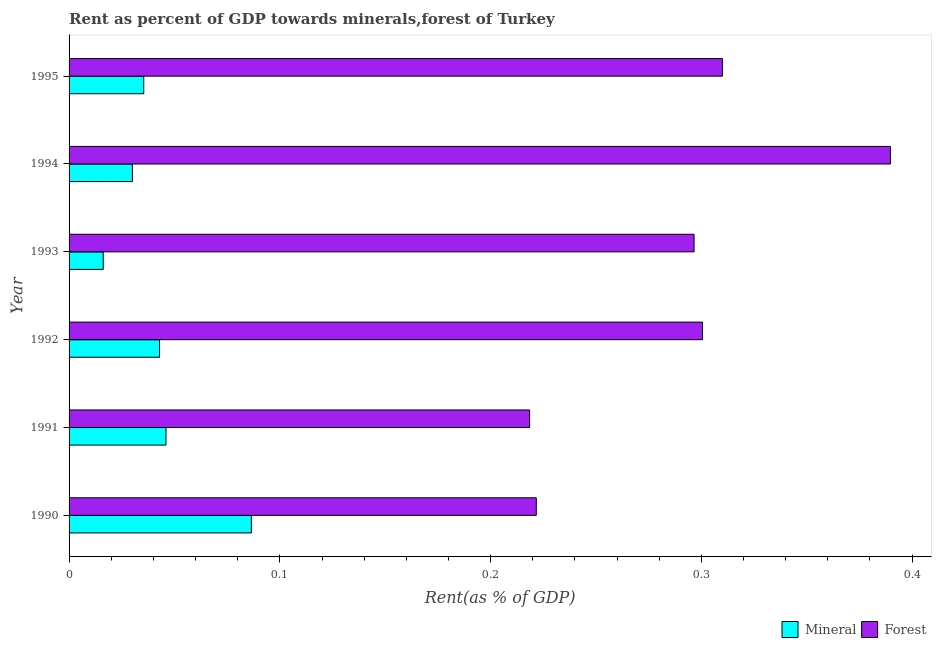How many different coloured bars are there?
Keep it short and to the point. 2. How many bars are there on the 4th tick from the top?
Your answer should be very brief. 2. How many bars are there on the 4th tick from the bottom?
Ensure brevity in your answer.  2. In how many cases, is the number of bars for a given year not equal to the number of legend labels?
Your answer should be very brief. 0. What is the forest rent in 1994?
Offer a very short reply. 0.39. Across all years, what is the maximum forest rent?
Give a very brief answer. 0.39. Across all years, what is the minimum mineral rent?
Offer a terse response. 0.02. In which year was the mineral rent maximum?
Make the answer very short. 1990. What is the total mineral rent in the graph?
Ensure brevity in your answer.  0.26. What is the difference between the forest rent in 1990 and that in 1992?
Offer a terse response. -0.08. What is the difference between the forest rent in 1991 and the mineral rent in 1992?
Provide a succinct answer. 0.18. What is the average forest rent per year?
Your response must be concise. 0.29. In the year 1992, what is the difference between the mineral rent and forest rent?
Your answer should be very brief. -0.26. What is the ratio of the mineral rent in 1991 to that in 1993?
Give a very brief answer. 2.84. Is the mineral rent in 1991 less than that in 1995?
Provide a short and direct response. No. Is the difference between the forest rent in 1991 and 1992 greater than the difference between the mineral rent in 1991 and 1992?
Keep it short and to the point. No. What is the difference between the highest and the second highest forest rent?
Make the answer very short. 0.08. What is the difference between the highest and the lowest mineral rent?
Offer a terse response. 0.07. Is the sum of the forest rent in 1990 and 1995 greater than the maximum mineral rent across all years?
Give a very brief answer. Yes. What does the 1st bar from the top in 1990 represents?
Provide a succinct answer. Forest. What does the 2nd bar from the bottom in 1992 represents?
Keep it short and to the point. Forest. Are all the bars in the graph horizontal?
Ensure brevity in your answer.  Yes. How many years are there in the graph?
Your answer should be compact. 6. What is the difference between two consecutive major ticks on the X-axis?
Provide a succinct answer. 0.1. Does the graph contain any zero values?
Provide a succinct answer. No. How many legend labels are there?
Your answer should be very brief. 2. What is the title of the graph?
Give a very brief answer. Rent as percent of GDP towards minerals,forest of Turkey. Does "Lower secondary rate" appear as one of the legend labels in the graph?
Offer a very short reply. No. What is the label or title of the X-axis?
Your answer should be compact. Rent(as % of GDP). What is the Rent(as % of GDP) of Mineral in 1990?
Make the answer very short. 0.09. What is the Rent(as % of GDP) in Forest in 1990?
Keep it short and to the point. 0.22. What is the Rent(as % of GDP) in Mineral in 1991?
Your answer should be compact. 0.05. What is the Rent(as % of GDP) in Forest in 1991?
Provide a short and direct response. 0.22. What is the Rent(as % of GDP) in Mineral in 1992?
Make the answer very short. 0.04. What is the Rent(as % of GDP) of Forest in 1992?
Provide a short and direct response. 0.3. What is the Rent(as % of GDP) of Mineral in 1993?
Your answer should be compact. 0.02. What is the Rent(as % of GDP) of Forest in 1993?
Your response must be concise. 0.3. What is the Rent(as % of GDP) of Mineral in 1994?
Give a very brief answer. 0.03. What is the Rent(as % of GDP) of Forest in 1994?
Offer a very short reply. 0.39. What is the Rent(as % of GDP) of Mineral in 1995?
Provide a succinct answer. 0.04. What is the Rent(as % of GDP) of Forest in 1995?
Provide a succinct answer. 0.31. Across all years, what is the maximum Rent(as % of GDP) in Mineral?
Make the answer very short. 0.09. Across all years, what is the maximum Rent(as % of GDP) of Forest?
Offer a terse response. 0.39. Across all years, what is the minimum Rent(as % of GDP) of Mineral?
Offer a terse response. 0.02. Across all years, what is the minimum Rent(as % of GDP) in Forest?
Provide a succinct answer. 0.22. What is the total Rent(as % of GDP) of Mineral in the graph?
Offer a very short reply. 0.26. What is the total Rent(as % of GDP) in Forest in the graph?
Ensure brevity in your answer.  1.74. What is the difference between the Rent(as % of GDP) of Mineral in 1990 and that in 1991?
Your answer should be very brief. 0.04. What is the difference between the Rent(as % of GDP) of Forest in 1990 and that in 1991?
Ensure brevity in your answer.  0. What is the difference between the Rent(as % of GDP) in Mineral in 1990 and that in 1992?
Your response must be concise. 0.04. What is the difference between the Rent(as % of GDP) of Forest in 1990 and that in 1992?
Your answer should be compact. -0.08. What is the difference between the Rent(as % of GDP) of Mineral in 1990 and that in 1993?
Make the answer very short. 0.07. What is the difference between the Rent(as % of GDP) in Forest in 1990 and that in 1993?
Your response must be concise. -0.07. What is the difference between the Rent(as % of GDP) in Mineral in 1990 and that in 1994?
Keep it short and to the point. 0.06. What is the difference between the Rent(as % of GDP) of Forest in 1990 and that in 1994?
Your response must be concise. -0.17. What is the difference between the Rent(as % of GDP) of Mineral in 1990 and that in 1995?
Provide a succinct answer. 0.05. What is the difference between the Rent(as % of GDP) in Forest in 1990 and that in 1995?
Your response must be concise. -0.09. What is the difference between the Rent(as % of GDP) in Mineral in 1991 and that in 1992?
Ensure brevity in your answer.  0. What is the difference between the Rent(as % of GDP) of Forest in 1991 and that in 1992?
Provide a short and direct response. -0.08. What is the difference between the Rent(as % of GDP) in Mineral in 1991 and that in 1993?
Ensure brevity in your answer.  0.03. What is the difference between the Rent(as % of GDP) in Forest in 1991 and that in 1993?
Ensure brevity in your answer.  -0.08. What is the difference between the Rent(as % of GDP) of Mineral in 1991 and that in 1994?
Your answer should be very brief. 0.02. What is the difference between the Rent(as % of GDP) of Forest in 1991 and that in 1994?
Offer a terse response. -0.17. What is the difference between the Rent(as % of GDP) in Mineral in 1991 and that in 1995?
Your response must be concise. 0.01. What is the difference between the Rent(as % of GDP) of Forest in 1991 and that in 1995?
Your answer should be compact. -0.09. What is the difference between the Rent(as % of GDP) in Mineral in 1992 and that in 1993?
Provide a short and direct response. 0.03. What is the difference between the Rent(as % of GDP) in Forest in 1992 and that in 1993?
Offer a terse response. 0. What is the difference between the Rent(as % of GDP) in Mineral in 1992 and that in 1994?
Your answer should be very brief. 0.01. What is the difference between the Rent(as % of GDP) of Forest in 1992 and that in 1994?
Provide a short and direct response. -0.09. What is the difference between the Rent(as % of GDP) in Mineral in 1992 and that in 1995?
Provide a short and direct response. 0.01. What is the difference between the Rent(as % of GDP) of Forest in 1992 and that in 1995?
Your answer should be compact. -0.01. What is the difference between the Rent(as % of GDP) in Mineral in 1993 and that in 1994?
Your answer should be very brief. -0.01. What is the difference between the Rent(as % of GDP) of Forest in 1993 and that in 1994?
Keep it short and to the point. -0.09. What is the difference between the Rent(as % of GDP) in Mineral in 1993 and that in 1995?
Offer a terse response. -0.02. What is the difference between the Rent(as % of GDP) in Forest in 1993 and that in 1995?
Offer a terse response. -0.01. What is the difference between the Rent(as % of GDP) in Mineral in 1994 and that in 1995?
Ensure brevity in your answer.  -0.01. What is the difference between the Rent(as % of GDP) in Forest in 1994 and that in 1995?
Provide a short and direct response. 0.08. What is the difference between the Rent(as % of GDP) of Mineral in 1990 and the Rent(as % of GDP) of Forest in 1991?
Your answer should be compact. -0.13. What is the difference between the Rent(as % of GDP) in Mineral in 1990 and the Rent(as % of GDP) in Forest in 1992?
Provide a succinct answer. -0.21. What is the difference between the Rent(as % of GDP) in Mineral in 1990 and the Rent(as % of GDP) in Forest in 1993?
Offer a very short reply. -0.21. What is the difference between the Rent(as % of GDP) in Mineral in 1990 and the Rent(as % of GDP) in Forest in 1994?
Give a very brief answer. -0.3. What is the difference between the Rent(as % of GDP) in Mineral in 1990 and the Rent(as % of GDP) in Forest in 1995?
Your answer should be compact. -0.22. What is the difference between the Rent(as % of GDP) in Mineral in 1991 and the Rent(as % of GDP) in Forest in 1992?
Keep it short and to the point. -0.25. What is the difference between the Rent(as % of GDP) in Mineral in 1991 and the Rent(as % of GDP) in Forest in 1993?
Make the answer very short. -0.25. What is the difference between the Rent(as % of GDP) of Mineral in 1991 and the Rent(as % of GDP) of Forest in 1994?
Give a very brief answer. -0.34. What is the difference between the Rent(as % of GDP) in Mineral in 1991 and the Rent(as % of GDP) in Forest in 1995?
Ensure brevity in your answer.  -0.26. What is the difference between the Rent(as % of GDP) of Mineral in 1992 and the Rent(as % of GDP) of Forest in 1993?
Make the answer very short. -0.25. What is the difference between the Rent(as % of GDP) of Mineral in 1992 and the Rent(as % of GDP) of Forest in 1994?
Provide a succinct answer. -0.35. What is the difference between the Rent(as % of GDP) of Mineral in 1992 and the Rent(as % of GDP) of Forest in 1995?
Give a very brief answer. -0.27. What is the difference between the Rent(as % of GDP) of Mineral in 1993 and the Rent(as % of GDP) of Forest in 1994?
Make the answer very short. -0.37. What is the difference between the Rent(as % of GDP) of Mineral in 1993 and the Rent(as % of GDP) of Forest in 1995?
Provide a short and direct response. -0.29. What is the difference between the Rent(as % of GDP) of Mineral in 1994 and the Rent(as % of GDP) of Forest in 1995?
Your answer should be compact. -0.28. What is the average Rent(as % of GDP) in Mineral per year?
Offer a terse response. 0.04. What is the average Rent(as % of GDP) in Forest per year?
Your response must be concise. 0.29. In the year 1990, what is the difference between the Rent(as % of GDP) of Mineral and Rent(as % of GDP) of Forest?
Offer a terse response. -0.14. In the year 1991, what is the difference between the Rent(as % of GDP) in Mineral and Rent(as % of GDP) in Forest?
Make the answer very short. -0.17. In the year 1992, what is the difference between the Rent(as % of GDP) of Mineral and Rent(as % of GDP) of Forest?
Offer a terse response. -0.26. In the year 1993, what is the difference between the Rent(as % of GDP) in Mineral and Rent(as % of GDP) in Forest?
Make the answer very short. -0.28. In the year 1994, what is the difference between the Rent(as % of GDP) in Mineral and Rent(as % of GDP) in Forest?
Keep it short and to the point. -0.36. In the year 1995, what is the difference between the Rent(as % of GDP) in Mineral and Rent(as % of GDP) in Forest?
Give a very brief answer. -0.27. What is the ratio of the Rent(as % of GDP) of Mineral in 1990 to that in 1991?
Give a very brief answer. 1.88. What is the ratio of the Rent(as % of GDP) of Forest in 1990 to that in 1991?
Your answer should be compact. 1.01. What is the ratio of the Rent(as % of GDP) in Mineral in 1990 to that in 1992?
Provide a short and direct response. 2.02. What is the ratio of the Rent(as % of GDP) in Forest in 1990 to that in 1992?
Give a very brief answer. 0.74. What is the ratio of the Rent(as % of GDP) of Mineral in 1990 to that in 1993?
Offer a terse response. 5.34. What is the ratio of the Rent(as % of GDP) in Forest in 1990 to that in 1993?
Make the answer very short. 0.75. What is the ratio of the Rent(as % of GDP) of Mineral in 1990 to that in 1994?
Provide a short and direct response. 2.88. What is the ratio of the Rent(as % of GDP) in Forest in 1990 to that in 1994?
Provide a short and direct response. 0.57. What is the ratio of the Rent(as % of GDP) in Mineral in 1990 to that in 1995?
Make the answer very short. 2.44. What is the ratio of the Rent(as % of GDP) of Forest in 1990 to that in 1995?
Provide a short and direct response. 0.72. What is the ratio of the Rent(as % of GDP) in Mineral in 1991 to that in 1992?
Give a very brief answer. 1.07. What is the ratio of the Rent(as % of GDP) of Forest in 1991 to that in 1992?
Provide a succinct answer. 0.73. What is the ratio of the Rent(as % of GDP) of Mineral in 1991 to that in 1993?
Your response must be concise. 2.84. What is the ratio of the Rent(as % of GDP) of Forest in 1991 to that in 1993?
Make the answer very short. 0.74. What is the ratio of the Rent(as % of GDP) of Mineral in 1991 to that in 1994?
Your response must be concise. 1.53. What is the ratio of the Rent(as % of GDP) of Forest in 1991 to that in 1994?
Your response must be concise. 0.56. What is the ratio of the Rent(as % of GDP) in Mineral in 1991 to that in 1995?
Ensure brevity in your answer.  1.3. What is the ratio of the Rent(as % of GDP) of Forest in 1991 to that in 1995?
Ensure brevity in your answer.  0.7. What is the ratio of the Rent(as % of GDP) in Mineral in 1992 to that in 1993?
Your answer should be compact. 2.65. What is the ratio of the Rent(as % of GDP) in Forest in 1992 to that in 1993?
Your answer should be compact. 1.01. What is the ratio of the Rent(as % of GDP) in Mineral in 1992 to that in 1994?
Provide a short and direct response. 1.43. What is the ratio of the Rent(as % of GDP) of Forest in 1992 to that in 1994?
Make the answer very short. 0.77. What is the ratio of the Rent(as % of GDP) of Mineral in 1992 to that in 1995?
Offer a very short reply. 1.21. What is the ratio of the Rent(as % of GDP) in Forest in 1992 to that in 1995?
Make the answer very short. 0.97. What is the ratio of the Rent(as % of GDP) of Mineral in 1993 to that in 1994?
Give a very brief answer. 0.54. What is the ratio of the Rent(as % of GDP) in Forest in 1993 to that in 1994?
Give a very brief answer. 0.76. What is the ratio of the Rent(as % of GDP) of Mineral in 1993 to that in 1995?
Provide a short and direct response. 0.46. What is the ratio of the Rent(as % of GDP) of Forest in 1993 to that in 1995?
Your answer should be very brief. 0.96. What is the ratio of the Rent(as % of GDP) of Mineral in 1994 to that in 1995?
Ensure brevity in your answer.  0.85. What is the ratio of the Rent(as % of GDP) of Forest in 1994 to that in 1995?
Make the answer very short. 1.26. What is the difference between the highest and the second highest Rent(as % of GDP) in Mineral?
Offer a terse response. 0.04. What is the difference between the highest and the second highest Rent(as % of GDP) in Forest?
Your response must be concise. 0.08. What is the difference between the highest and the lowest Rent(as % of GDP) of Mineral?
Your answer should be very brief. 0.07. What is the difference between the highest and the lowest Rent(as % of GDP) of Forest?
Your response must be concise. 0.17. 